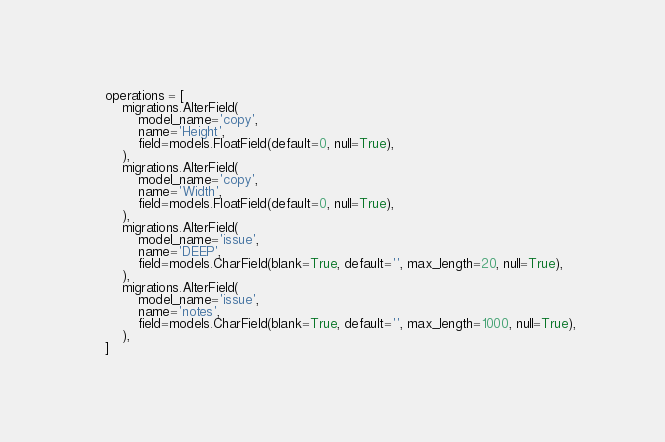<code> <loc_0><loc_0><loc_500><loc_500><_Python_>
    operations = [
        migrations.AlterField(
            model_name='copy',
            name='Height',
            field=models.FloatField(default=0, null=True),
        ),
        migrations.AlterField(
            model_name='copy',
            name='Width',
            field=models.FloatField(default=0, null=True),
        ),
        migrations.AlterField(
            model_name='issue',
            name='DEEP',
            field=models.CharField(blank=True, default='', max_length=20, null=True),
        ),
        migrations.AlterField(
            model_name='issue',
            name='notes',
            field=models.CharField(blank=True, default='', max_length=1000, null=True),
        ),
    ]
</code> 